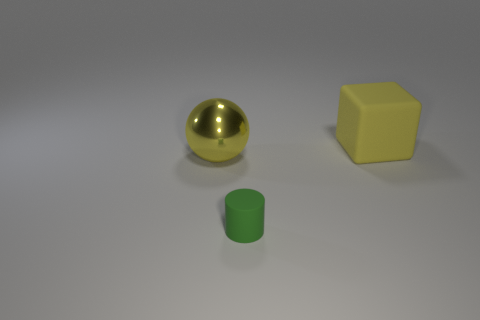Add 1 green rubber objects. How many objects exist? 4 Subtract all balls. How many objects are left? 2 Add 3 big balls. How many big balls are left? 4 Add 3 red cubes. How many red cubes exist? 3 Subtract 0 yellow cylinders. How many objects are left? 3 Subtract all small purple objects. Subtract all big shiny things. How many objects are left? 2 